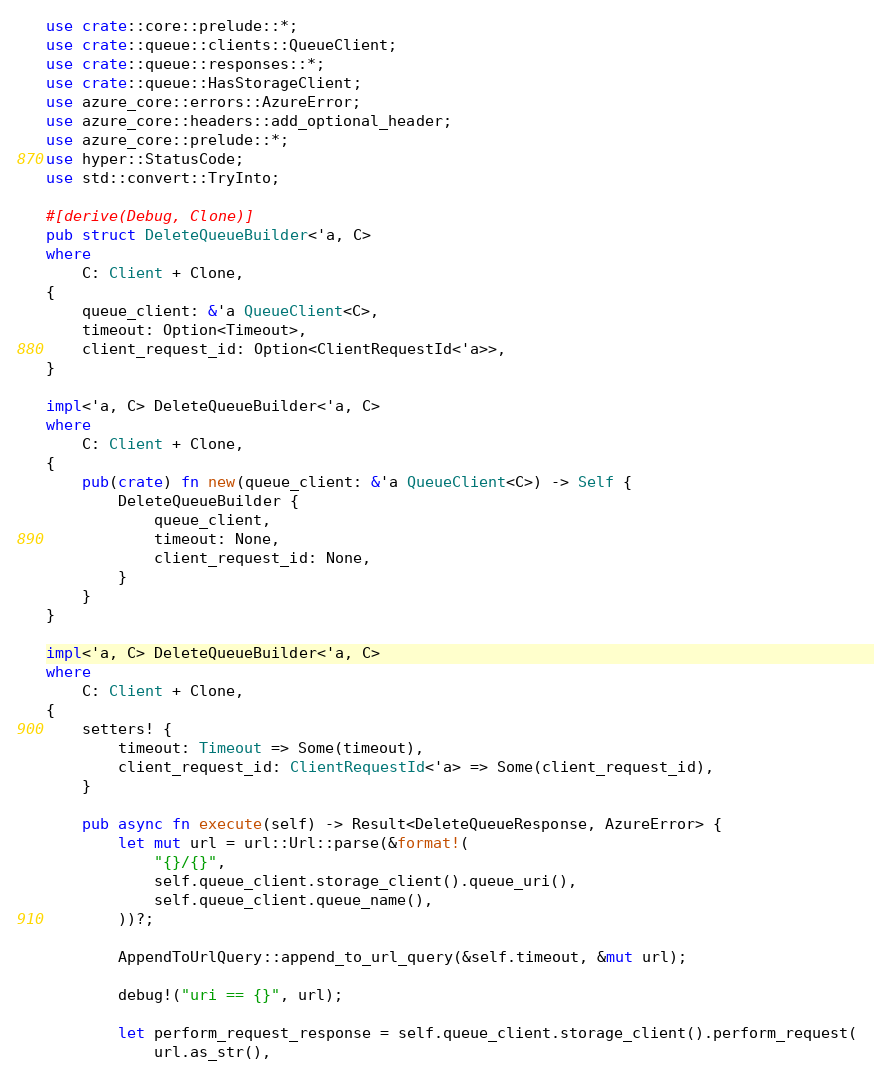<code> <loc_0><loc_0><loc_500><loc_500><_Rust_>use crate::core::prelude::*;
use crate::queue::clients::QueueClient;
use crate::queue::responses::*;
use crate::queue::HasStorageClient;
use azure_core::errors::AzureError;
use azure_core::headers::add_optional_header;
use azure_core::prelude::*;
use hyper::StatusCode;
use std::convert::TryInto;

#[derive(Debug, Clone)]
pub struct DeleteQueueBuilder<'a, C>
where
    C: Client + Clone,
{
    queue_client: &'a QueueClient<C>,
    timeout: Option<Timeout>,
    client_request_id: Option<ClientRequestId<'a>>,
}

impl<'a, C> DeleteQueueBuilder<'a, C>
where
    C: Client + Clone,
{
    pub(crate) fn new(queue_client: &'a QueueClient<C>) -> Self {
        DeleteQueueBuilder {
            queue_client,
            timeout: None,
            client_request_id: None,
        }
    }
}

impl<'a, C> DeleteQueueBuilder<'a, C>
where
    C: Client + Clone,
{
    setters! {
        timeout: Timeout => Some(timeout),
        client_request_id: ClientRequestId<'a> => Some(client_request_id),
    }

    pub async fn execute(self) -> Result<DeleteQueueResponse, AzureError> {
        let mut url = url::Url::parse(&format!(
            "{}/{}",
            self.queue_client.storage_client().queue_uri(),
            self.queue_client.queue_name(),
        ))?;

        AppendToUrlQuery::append_to_url_query(&self.timeout, &mut url);

        debug!("uri == {}", url);

        let perform_request_response = self.queue_client.storage_client().perform_request(
            url.as_str(),</code> 